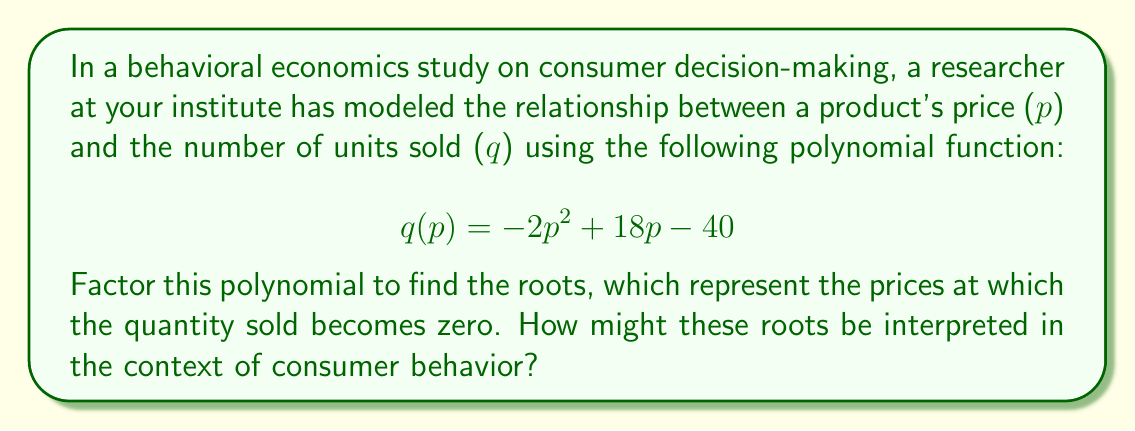Can you answer this question? To factor this polynomial, we'll follow these steps:

1) First, recognize that this is a quadratic equation in the form $ax^2 + bx + c$, where:
   $a = -2$, $b = 18$, and $c = -40$

2) We can use the quadratic formula: $x = \frac{-b \pm \sqrt{b^2 - 4ac}}{2a}$

3) Substituting our values:
   $$p = \frac{-18 \pm \sqrt{18^2 - 4(-2)(-40)}}{2(-2)}$$

4) Simplify under the square root:
   $$p = \frac{-18 \pm \sqrt{324 - 320}}{-4} = \frac{-18 \pm \sqrt{4}}{-4} = \frac{-18 \pm 2}{-4}$$

5) This gives us two solutions:
   $$p = \frac{-18 + 2}{-4} = \frac{-16}{-4} = 4$$
   $$p = \frac{-18 - 2}{-4} = \frac{-20}{-4} = 5$$

6) Therefore, we can factor the polynomial as:
   $$q(p) = -2(p - 4)(p - 5)$$

Interpretation: The roots (4 and 5) represent the prices at which the quantity sold becomes zero. In the context of consumer behavior:

- At a price of $4 or below, all available units would be sold (demand exceeds supply).
- At a price of $5 or above, no units would be sold (price is too high for any consumer).
- Between $4 and $5, there's a range where some units are sold, with the maximum quantity sold at the vertex of the parabola.

This model captures the basic economic principle that demand decreases as price increases, but in a non-linear fashion that could reflect factors like perceived value, market saturation, or price elasticity of demand.
Answer: The factored polynomial is: $$q(p) = -2(p - 4)(p - 5)$$
The roots are $p = 4$ and $p = 5$, representing the lower and upper price bounds for any sales to occur. 